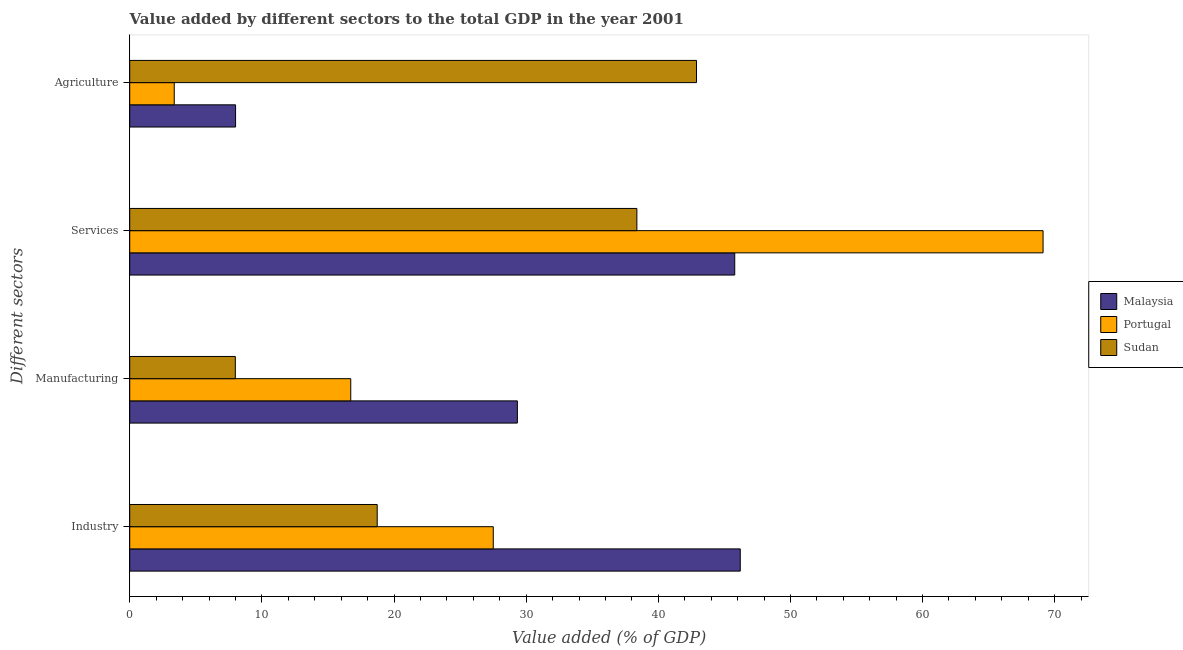How many different coloured bars are there?
Provide a succinct answer. 3. How many bars are there on the 2nd tick from the top?
Give a very brief answer. 3. What is the label of the 1st group of bars from the top?
Give a very brief answer. Agriculture. What is the value added by services sector in Malaysia?
Your answer should be compact. 45.79. Across all countries, what is the maximum value added by manufacturing sector?
Provide a short and direct response. 29.34. Across all countries, what is the minimum value added by industrial sector?
Offer a very short reply. 18.73. In which country was the value added by manufacturing sector maximum?
Provide a succinct answer. Malaysia. In which country was the value added by manufacturing sector minimum?
Your answer should be compact. Sudan. What is the total value added by services sector in the graph?
Make the answer very short. 153.28. What is the difference between the value added by services sector in Portugal and that in Malaysia?
Give a very brief answer. 23.33. What is the difference between the value added by industrial sector in Sudan and the value added by agricultural sector in Malaysia?
Give a very brief answer. 10.72. What is the average value added by services sector per country?
Your answer should be compact. 51.09. What is the difference between the value added by agricultural sector and value added by industrial sector in Malaysia?
Ensure brevity in your answer.  -38.19. In how many countries, is the value added by manufacturing sector greater than 40 %?
Offer a very short reply. 0. What is the ratio of the value added by manufacturing sector in Malaysia to that in Sudan?
Give a very brief answer. 3.67. Is the value added by industrial sector in Sudan less than that in Portugal?
Provide a succinct answer. Yes. Is the difference between the value added by industrial sector in Portugal and Sudan greater than the difference between the value added by agricultural sector in Portugal and Sudan?
Your response must be concise. Yes. What is the difference between the highest and the second highest value added by manufacturing sector?
Make the answer very short. 12.61. What is the difference between the highest and the lowest value added by industrial sector?
Ensure brevity in your answer.  27.48. Is it the case that in every country, the sum of the value added by industrial sector and value added by services sector is greater than the sum of value added by agricultural sector and value added by manufacturing sector?
Offer a terse response. Yes. What does the 1st bar from the top in Agriculture represents?
Your response must be concise. Sudan. What does the 3rd bar from the bottom in Industry represents?
Your answer should be compact. Sudan. Is it the case that in every country, the sum of the value added by industrial sector and value added by manufacturing sector is greater than the value added by services sector?
Your answer should be compact. No. How many bars are there?
Your answer should be compact. 12. Does the graph contain any zero values?
Your response must be concise. No. Does the graph contain grids?
Ensure brevity in your answer.  No. How many legend labels are there?
Your response must be concise. 3. What is the title of the graph?
Give a very brief answer. Value added by different sectors to the total GDP in the year 2001. Does "Latvia" appear as one of the legend labels in the graph?
Provide a short and direct response. No. What is the label or title of the X-axis?
Make the answer very short. Value added (% of GDP). What is the label or title of the Y-axis?
Provide a short and direct response. Different sectors. What is the Value added (% of GDP) of Malaysia in Industry?
Make the answer very short. 46.2. What is the Value added (% of GDP) in Portugal in Industry?
Give a very brief answer. 27.51. What is the Value added (% of GDP) in Sudan in Industry?
Your answer should be compact. 18.73. What is the Value added (% of GDP) in Malaysia in Manufacturing?
Your response must be concise. 29.34. What is the Value added (% of GDP) of Portugal in Manufacturing?
Ensure brevity in your answer.  16.73. What is the Value added (% of GDP) in Sudan in Manufacturing?
Your answer should be compact. 7.99. What is the Value added (% of GDP) of Malaysia in Services?
Give a very brief answer. 45.79. What is the Value added (% of GDP) of Portugal in Services?
Keep it short and to the point. 69.12. What is the Value added (% of GDP) of Sudan in Services?
Provide a succinct answer. 38.38. What is the Value added (% of GDP) of Malaysia in Agriculture?
Your answer should be very brief. 8.01. What is the Value added (% of GDP) of Portugal in Agriculture?
Provide a short and direct response. 3.37. What is the Value added (% of GDP) of Sudan in Agriculture?
Give a very brief answer. 42.89. Across all Different sectors, what is the maximum Value added (% of GDP) in Malaysia?
Keep it short and to the point. 46.2. Across all Different sectors, what is the maximum Value added (% of GDP) in Portugal?
Provide a succinct answer. 69.12. Across all Different sectors, what is the maximum Value added (% of GDP) of Sudan?
Make the answer very short. 42.89. Across all Different sectors, what is the minimum Value added (% of GDP) of Malaysia?
Ensure brevity in your answer.  8.01. Across all Different sectors, what is the minimum Value added (% of GDP) of Portugal?
Your answer should be very brief. 3.37. Across all Different sectors, what is the minimum Value added (% of GDP) of Sudan?
Provide a succinct answer. 7.99. What is the total Value added (% of GDP) in Malaysia in the graph?
Make the answer very short. 129.34. What is the total Value added (% of GDP) in Portugal in the graph?
Your answer should be very brief. 116.73. What is the total Value added (% of GDP) of Sudan in the graph?
Offer a terse response. 107.99. What is the difference between the Value added (% of GDP) of Malaysia in Industry and that in Manufacturing?
Your answer should be compact. 16.87. What is the difference between the Value added (% of GDP) of Portugal in Industry and that in Manufacturing?
Your answer should be compact. 10.79. What is the difference between the Value added (% of GDP) in Sudan in Industry and that in Manufacturing?
Provide a succinct answer. 10.74. What is the difference between the Value added (% of GDP) in Malaysia in Industry and that in Services?
Give a very brief answer. 0.42. What is the difference between the Value added (% of GDP) in Portugal in Industry and that in Services?
Ensure brevity in your answer.  -41.61. What is the difference between the Value added (% of GDP) of Sudan in Industry and that in Services?
Your answer should be compact. -19.65. What is the difference between the Value added (% of GDP) of Malaysia in Industry and that in Agriculture?
Your answer should be very brief. 38.19. What is the difference between the Value added (% of GDP) of Portugal in Industry and that in Agriculture?
Offer a very short reply. 24.14. What is the difference between the Value added (% of GDP) in Sudan in Industry and that in Agriculture?
Your answer should be compact. -24.16. What is the difference between the Value added (% of GDP) in Malaysia in Manufacturing and that in Services?
Offer a very short reply. -16.45. What is the difference between the Value added (% of GDP) in Portugal in Manufacturing and that in Services?
Make the answer very short. -52.39. What is the difference between the Value added (% of GDP) in Sudan in Manufacturing and that in Services?
Offer a terse response. -30.39. What is the difference between the Value added (% of GDP) of Malaysia in Manufacturing and that in Agriculture?
Give a very brief answer. 21.33. What is the difference between the Value added (% of GDP) of Portugal in Manufacturing and that in Agriculture?
Provide a succinct answer. 13.36. What is the difference between the Value added (% of GDP) in Sudan in Manufacturing and that in Agriculture?
Your answer should be compact. -34.9. What is the difference between the Value added (% of GDP) of Malaysia in Services and that in Agriculture?
Make the answer very short. 37.77. What is the difference between the Value added (% of GDP) of Portugal in Services and that in Agriculture?
Your response must be concise. 65.75. What is the difference between the Value added (% of GDP) in Sudan in Services and that in Agriculture?
Keep it short and to the point. -4.51. What is the difference between the Value added (% of GDP) in Malaysia in Industry and the Value added (% of GDP) in Portugal in Manufacturing?
Give a very brief answer. 29.48. What is the difference between the Value added (% of GDP) of Malaysia in Industry and the Value added (% of GDP) of Sudan in Manufacturing?
Provide a succinct answer. 38.21. What is the difference between the Value added (% of GDP) in Portugal in Industry and the Value added (% of GDP) in Sudan in Manufacturing?
Your response must be concise. 19.52. What is the difference between the Value added (% of GDP) in Malaysia in Industry and the Value added (% of GDP) in Portugal in Services?
Give a very brief answer. -22.92. What is the difference between the Value added (% of GDP) in Malaysia in Industry and the Value added (% of GDP) in Sudan in Services?
Offer a terse response. 7.82. What is the difference between the Value added (% of GDP) in Portugal in Industry and the Value added (% of GDP) in Sudan in Services?
Offer a terse response. -10.87. What is the difference between the Value added (% of GDP) in Malaysia in Industry and the Value added (% of GDP) in Portugal in Agriculture?
Your answer should be very brief. 42.83. What is the difference between the Value added (% of GDP) of Malaysia in Industry and the Value added (% of GDP) of Sudan in Agriculture?
Give a very brief answer. 3.31. What is the difference between the Value added (% of GDP) in Portugal in Industry and the Value added (% of GDP) in Sudan in Agriculture?
Offer a terse response. -15.38. What is the difference between the Value added (% of GDP) of Malaysia in Manufacturing and the Value added (% of GDP) of Portugal in Services?
Provide a succinct answer. -39.78. What is the difference between the Value added (% of GDP) of Malaysia in Manufacturing and the Value added (% of GDP) of Sudan in Services?
Make the answer very short. -9.04. What is the difference between the Value added (% of GDP) of Portugal in Manufacturing and the Value added (% of GDP) of Sudan in Services?
Keep it short and to the point. -21.65. What is the difference between the Value added (% of GDP) in Malaysia in Manufacturing and the Value added (% of GDP) in Portugal in Agriculture?
Offer a terse response. 25.97. What is the difference between the Value added (% of GDP) in Malaysia in Manufacturing and the Value added (% of GDP) in Sudan in Agriculture?
Your answer should be very brief. -13.56. What is the difference between the Value added (% of GDP) in Portugal in Manufacturing and the Value added (% of GDP) in Sudan in Agriculture?
Provide a succinct answer. -26.17. What is the difference between the Value added (% of GDP) in Malaysia in Services and the Value added (% of GDP) in Portugal in Agriculture?
Provide a succinct answer. 42.42. What is the difference between the Value added (% of GDP) in Malaysia in Services and the Value added (% of GDP) in Sudan in Agriculture?
Make the answer very short. 2.89. What is the difference between the Value added (% of GDP) in Portugal in Services and the Value added (% of GDP) in Sudan in Agriculture?
Make the answer very short. 26.23. What is the average Value added (% of GDP) of Malaysia per Different sectors?
Offer a terse response. 32.33. What is the average Value added (% of GDP) of Portugal per Different sectors?
Provide a succinct answer. 29.18. What is the average Value added (% of GDP) in Sudan per Different sectors?
Your answer should be very brief. 27. What is the difference between the Value added (% of GDP) in Malaysia and Value added (% of GDP) in Portugal in Industry?
Provide a short and direct response. 18.69. What is the difference between the Value added (% of GDP) of Malaysia and Value added (% of GDP) of Sudan in Industry?
Make the answer very short. 27.48. What is the difference between the Value added (% of GDP) of Portugal and Value added (% of GDP) of Sudan in Industry?
Offer a terse response. 8.78. What is the difference between the Value added (% of GDP) in Malaysia and Value added (% of GDP) in Portugal in Manufacturing?
Your response must be concise. 12.61. What is the difference between the Value added (% of GDP) of Malaysia and Value added (% of GDP) of Sudan in Manufacturing?
Make the answer very short. 21.34. What is the difference between the Value added (% of GDP) of Portugal and Value added (% of GDP) of Sudan in Manufacturing?
Provide a short and direct response. 8.74. What is the difference between the Value added (% of GDP) of Malaysia and Value added (% of GDP) of Portugal in Services?
Your answer should be compact. -23.33. What is the difference between the Value added (% of GDP) in Malaysia and Value added (% of GDP) in Sudan in Services?
Ensure brevity in your answer.  7.41. What is the difference between the Value added (% of GDP) of Portugal and Value added (% of GDP) of Sudan in Services?
Provide a succinct answer. 30.74. What is the difference between the Value added (% of GDP) in Malaysia and Value added (% of GDP) in Portugal in Agriculture?
Make the answer very short. 4.64. What is the difference between the Value added (% of GDP) in Malaysia and Value added (% of GDP) in Sudan in Agriculture?
Provide a succinct answer. -34.88. What is the difference between the Value added (% of GDP) in Portugal and Value added (% of GDP) in Sudan in Agriculture?
Your answer should be compact. -39.52. What is the ratio of the Value added (% of GDP) in Malaysia in Industry to that in Manufacturing?
Ensure brevity in your answer.  1.57. What is the ratio of the Value added (% of GDP) of Portugal in Industry to that in Manufacturing?
Your answer should be very brief. 1.64. What is the ratio of the Value added (% of GDP) of Sudan in Industry to that in Manufacturing?
Your answer should be very brief. 2.34. What is the ratio of the Value added (% of GDP) in Malaysia in Industry to that in Services?
Make the answer very short. 1.01. What is the ratio of the Value added (% of GDP) of Portugal in Industry to that in Services?
Offer a very short reply. 0.4. What is the ratio of the Value added (% of GDP) in Sudan in Industry to that in Services?
Offer a very short reply. 0.49. What is the ratio of the Value added (% of GDP) in Malaysia in Industry to that in Agriculture?
Make the answer very short. 5.77. What is the ratio of the Value added (% of GDP) of Portugal in Industry to that in Agriculture?
Your response must be concise. 8.16. What is the ratio of the Value added (% of GDP) of Sudan in Industry to that in Agriculture?
Offer a terse response. 0.44. What is the ratio of the Value added (% of GDP) of Malaysia in Manufacturing to that in Services?
Make the answer very short. 0.64. What is the ratio of the Value added (% of GDP) in Portugal in Manufacturing to that in Services?
Ensure brevity in your answer.  0.24. What is the ratio of the Value added (% of GDP) of Sudan in Manufacturing to that in Services?
Provide a short and direct response. 0.21. What is the ratio of the Value added (% of GDP) in Malaysia in Manufacturing to that in Agriculture?
Ensure brevity in your answer.  3.66. What is the ratio of the Value added (% of GDP) in Portugal in Manufacturing to that in Agriculture?
Make the answer very short. 4.96. What is the ratio of the Value added (% of GDP) of Sudan in Manufacturing to that in Agriculture?
Keep it short and to the point. 0.19. What is the ratio of the Value added (% of GDP) of Malaysia in Services to that in Agriculture?
Your answer should be compact. 5.72. What is the ratio of the Value added (% of GDP) of Portugal in Services to that in Agriculture?
Provide a short and direct response. 20.51. What is the ratio of the Value added (% of GDP) of Sudan in Services to that in Agriculture?
Provide a short and direct response. 0.89. What is the difference between the highest and the second highest Value added (% of GDP) of Malaysia?
Give a very brief answer. 0.42. What is the difference between the highest and the second highest Value added (% of GDP) of Portugal?
Provide a succinct answer. 41.61. What is the difference between the highest and the second highest Value added (% of GDP) of Sudan?
Make the answer very short. 4.51. What is the difference between the highest and the lowest Value added (% of GDP) in Malaysia?
Provide a succinct answer. 38.19. What is the difference between the highest and the lowest Value added (% of GDP) in Portugal?
Your answer should be very brief. 65.75. What is the difference between the highest and the lowest Value added (% of GDP) in Sudan?
Offer a terse response. 34.9. 